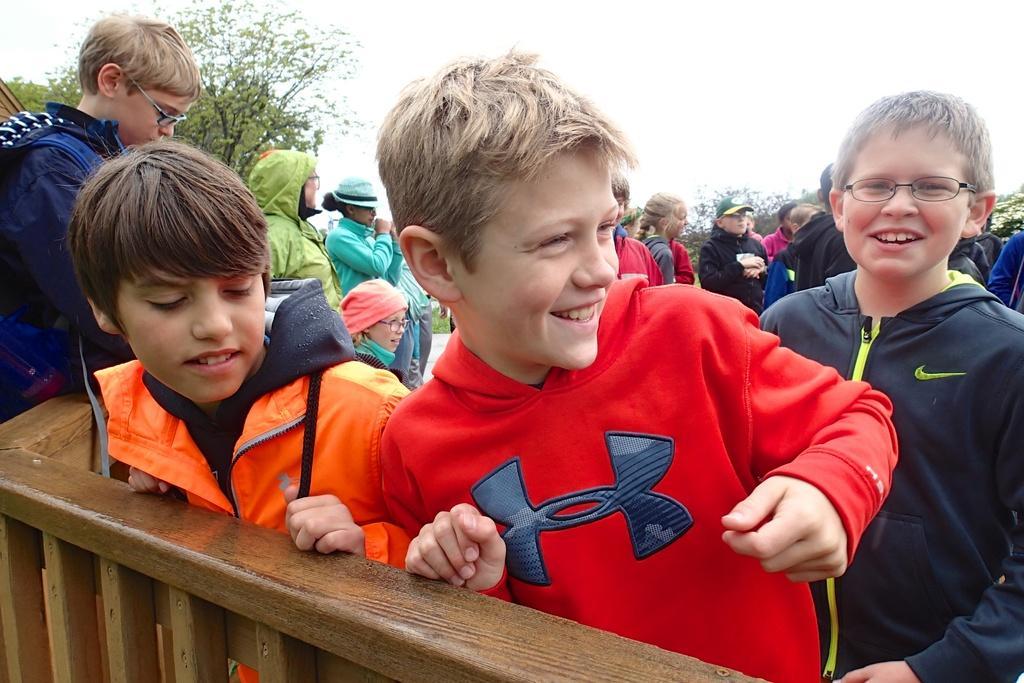How would you summarize this image in a sentence or two? In this image there are a group of people standing, and in the foreground there is a wooden railing. And in the background there are some trees, and at the top there is sky. 